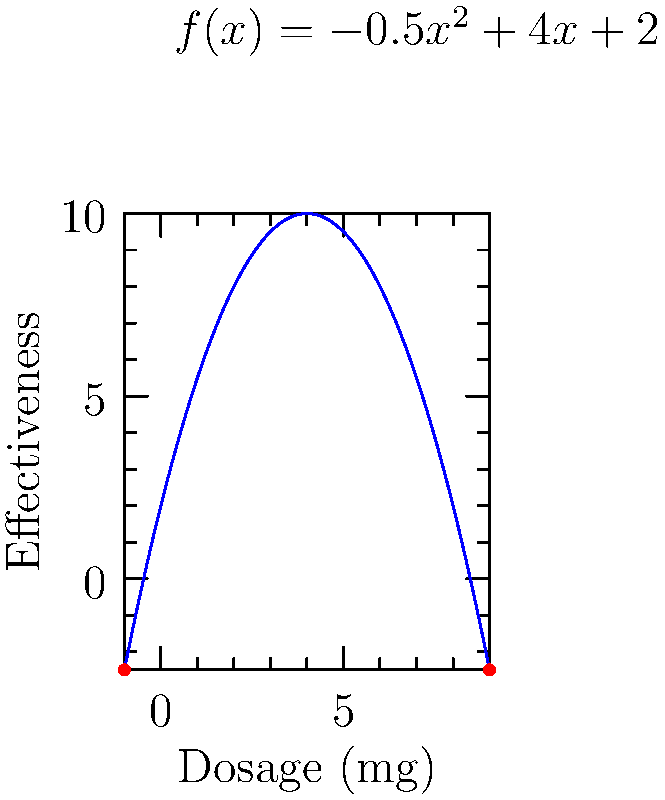A medication's effectiveness can be modeled by the function $f(x) = -0.5x^2 + 4x + 2$, where $x$ is the dosage in milligrams and $f(x)$ is the effectiveness score. What dosage maximizes the medication's effectiveness, and what is the maximum effectiveness score? To find the maximum effectiveness and optimal dosage:

1) The maximum of a parabolic function occurs at the vertex. For a parabola in the form $f(x) = ax^2 + bx + c$, the x-coordinate of the vertex is given by $x = -\frac{b}{2a}$.

2) In this case, $a = -0.5$, $b = 4$, and $c = 2$.

3) Optimal dosage: $x = -\frac{b}{2a} = -\frac{4}{2(-0.5)} = -\frac{4}{-1} = 4$ mg

4) To find the maximum effectiveness, substitute $x = 4$ into the original function:

   $f(4) = -0.5(4)^2 + 4(4) + 2$
         $= -0.5(16) + 16 + 2$
         $= -8 + 16 + 2$
         $= 10$

Therefore, the optimal dosage is 4 mg, and the maximum effectiveness score is 10.
Answer: Optimal dosage: 4 mg; Maximum effectiveness: 10 